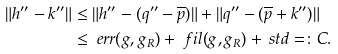Convert formula to latex. <formula><loc_0><loc_0><loc_500><loc_500>\| h ^ { \prime \prime } - k ^ { \prime \prime } \| & \leq \| h ^ { \prime \prime } - ( q ^ { \prime \prime } - \overline { p } ) \| + \| q ^ { \prime \prime } - ( \overline { p } + k ^ { \prime \prime } ) \| \\ & \leq \ e r r ( g , g _ { R } ) + \ f i l ( g , g _ { R } ) + \ s t d = \colon C .</formula> 